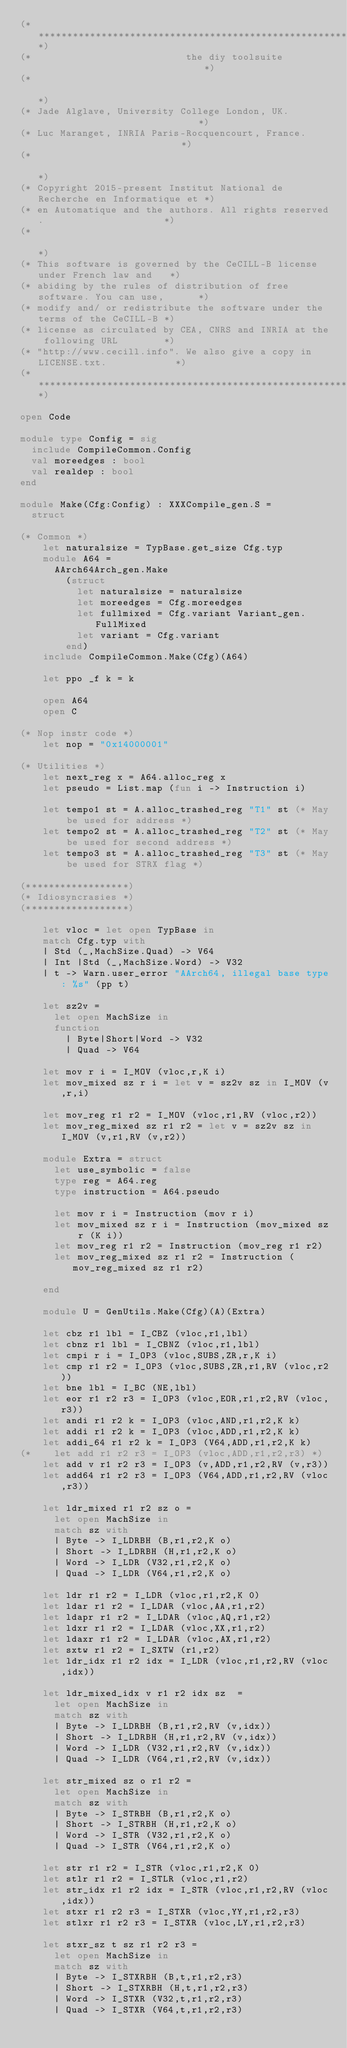<code> <loc_0><loc_0><loc_500><loc_500><_OCaml_>(****************************************************************************)
(*                           the diy toolsuite                              *)
(*                                                                          *)
(* Jade Alglave, University College London, UK.                             *)
(* Luc Maranget, INRIA Paris-Rocquencourt, France.                          *)
(*                                                                          *)
(* Copyright 2015-present Institut National de Recherche en Informatique et *)
(* en Automatique and the authors. All rights reserved.                     *)
(*                                                                          *)
(* This software is governed by the CeCILL-B license under French law and   *)
(* abiding by the rules of distribution of free software. You can use,      *)
(* modify and/ or redistribute the software under the terms of the CeCILL-B *)
(* license as circulated by CEA, CNRS and INRIA at the following URL        *)
(* "http://www.cecill.info". We also give a copy in LICENSE.txt.            *)
(****************************************************************************)

open Code

module type Config = sig
  include CompileCommon.Config
  val moreedges : bool
  val realdep : bool
end

module Make(Cfg:Config) : XXXCompile_gen.S =
  struct

(* Common *)
    let naturalsize = TypBase.get_size Cfg.typ
    module A64 =
      AArch64Arch_gen.Make
        (struct
          let naturalsize = naturalsize
          let moreedges = Cfg.moreedges
          let fullmixed = Cfg.variant Variant_gen.FullMixed
          let variant = Cfg.variant
        end)
    include CompileCommon.Make(Cfg)(A64)

    let ppo _f k = k

    open A64
    open C

(* Nop instr code *)
    let nop = "0x14000001"

(* Utilities *)
    let next_reg x = A64.alloc_reg x
    let pseudo = List.map (fun i -> Instruction i)

    let tempo1 st = A.alloc_trashed_reg "T1" st (* May be used for address *)
    let tempo2 st = A.alloc_trashed_reg "T2" st (* May be used for second address *)
    let tempo3 st = A.alloc_trashed_reg "T3" st (* May be used for STRX flag *)

(******************)
(* Idiosyncrasies *)
(******************)

    let vloc = let open TypBase in
    match Cfg.typ with
    | Std (_,MachSize.Quad) -> V64
    | Int |Std (_,MachSize.Word) -> V32
    | t -> Warn.user_error "AArch64, illegal base type: %s" (pp t)

    let sz2v =
      let open MachSize in
      function
        | Byte|Short|Word -> V32
        | Quad -> V64

    let mov r i = I_MOV (vloc,r,K i)
    let mov_mixed sz r i = let v = sz2v sz in I_MOV (v,r,i)

    let mov_reg r1 r2 = I_MOV (vloc,r1,RV (vloc,r2))
    let mov_reg_mixed sz r1 r2 = let v = sz2v sz in I_MOV (v,r1,RV (v,r2))

    module Extra = struct
      let use_symbolic = false
      type reg = A64.reg
      type instruction = A64.pseudo

      let mov r i = Instruction (mov r i)
      let mov_mixed sz r i = Instruction (mov_mixed sz r (K i))
      let mov_reg r1 r2 = Instruction (mov_reg r1 r2)
      let mov_reg_mixed sz r1 r2 = Instruction (mov_reg_mixed sz r1 r2)

    end

    module U = GenUtils.Make(Cfg)(A)(Extra)

    let cbz r1 lbl = I_CBZ (vloc,r1,lbl)
    let cbnz r1 lbl = I_CBNZ (vloc,r1,lbl)
    let cmpi r i = I_OP3 (vloc,SUBS,ZR,r,K i)
    let cmp r1 r2 = I_OP3 (vloc,SUBS,ZR,r1,RV (vloc,r2))
    let bne lbl = I_BC (NE,lbl)
    let eor r1 r2 r3 = I_OP3 (vloc,EOR,r1,r2,RV (vloc,r3))
    let andi r1 r2 k = I_OP3 (vloc,AND,r1,r2,K k)
    let addi r1 r2 k = I_OP3 (vloc,ADD,r1,r2,K k)
    let addi_64 r1 r2 k = I_OP3 (V64,ADD,r1,r2,K k)
(*    let add r1 r2 r3 = I_OP3 (vloc,ADD,r1,r2,r3) *)
    let add v r1 r2 r3 = I_OP3 (v,ADD,r1,r2,RV (v,r3))
    let add64 r1 r2 r3 = I_OP3 (V64,ADD,r1,r2,RV (vloc,r3))

    let ldr_mixed r1 r2 sz o =
      let open MachSize in
      match sz with
      | Byte -> I_LDRBH (B,r1,r2,K o)
      | Short -> I_LDRBH (H,r1,r2,K o)
      | Word -> I_LDR (V32,r1,r2,K o)
      | Quad -> I_LDR (V64,r1,r2,K o)

    let ldr r1 r2 = I_LDR (vloc,r1,r2,K 0)
    let ldar r1 r2 = I_LDAR (vloc,AA,r1,r2)
    let ldapr r1 r2 = I_LDAR (vloc,AQ,r1,r2)
    let ldxr r1 r2 = I_LDAR (vloc,XX,r1,r2)
    let ldaxr r1 r2 = I_LDAR (vloc,AX,r1,r2)
    let sxtw r1 r2 = I_SXTW (r1,r2)
    let ldr_idx r1 r2 idx = I_LDR (vloc,r1,r2,RV (vloc,idx))

    let ldr_mixed_idx v r1 r2 idx sz  =
      let open MachSize in
      match sz with
      | Byte -> I_LDRBH (B,r1,r2,RV (v,idx))
      | Short -> I_LDRBH (H,r1,r2,RV (v,idx))
      | Word -> I_LDR (V32,r1,r2,RV (v,idx))
      | Quad -> I_LDR (V64,r1,r2,RV (v,idx))

    let str_mixed sz o r1 r2 =
      let open MachSize in
      match sz with
      | Byte -> I_STRBH (B,r1,r2,K o)
      | Short -> I_STRBH (H,r1,r2,K o)
      | Word -> I_STR (V32,r1,r2,K o)
      | Quad -> I_STR (V64,r1,r2,K o)

    let str r1 r2 = I_STR (vloc,r1,r2,K 0)
    let stlr r1 r2 = I_STLR (vloc,r1,r2)
    let str_idx r1 r2 idx = I_STR (vloc,r1,r2,RV (vloc,idx))
    let stxr r1 r2 r3 = I_STXR (vloc,YY,r1,r2,r3)
    let stlxr r1 r2 r3 = I_STXR (vloc,LY,r1,r2,r3)

    let stxr_sz t sz r1 r2 r3 =
      let open MachSize in
      match sz with
      | Byte -> I_STXRBH (B,t,r1,r2,r3)
      | Short -> I_STXRBH (H,t,r1,r2,r3)
      | Word -> I_STXR (V32,t,r1,r2,r3)
      | Quad -> I_STXR (V64,t,r1,r2,r3)
</code> 